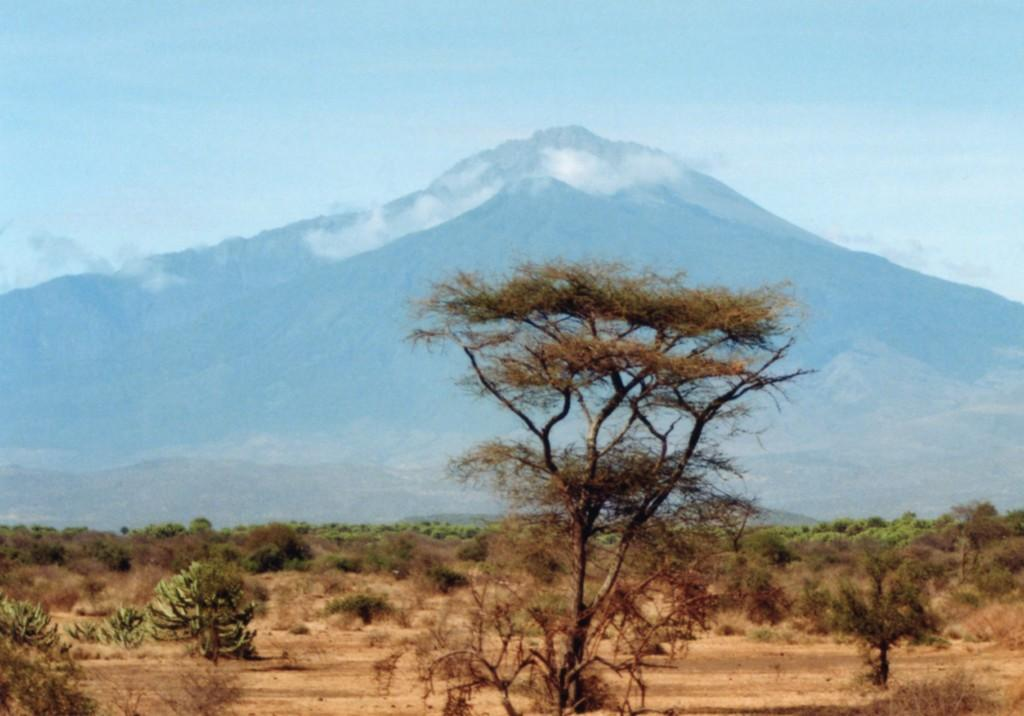What type of natural environment is depicted in the image? The image features many trees, suggesting a forest or wooded area. What can be seen in the distance behind the trees? There are mountains visible in the background of the image. What part of the sky is visible in the image? The sky is visible in the background of the image. What type of can is shown on the table in the image? There is no can or table present in the image; it features trees and mountains. How many carts are visible in the image? There are no carts present in the image. 